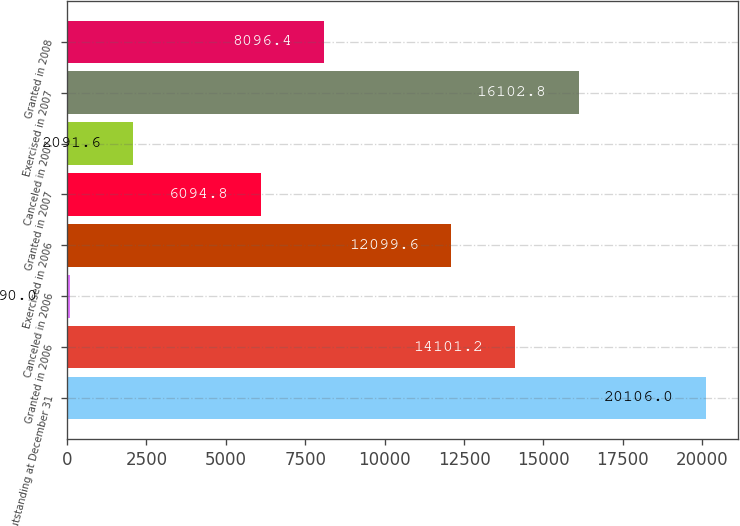<chart> <loc_0><loc_0><loc_500><loc_500><bar_chart><fcel>Outstanding at December 31<fcel>Granted in 2006<fcel>Canceled in 2006<fcel>Exercised in 2006<fcel>Granted in 2007<fcel>Canceled in 2007<fcel>Exercised in 2007<fcel>Granted in 2008<nl><fcel>20106<fcel>14101.2<fcel>90<fcel>12099.6<fcel>6094.8<fcel>2091.6<fcel>16102.8<fcel>8096.4<nl></chart> 